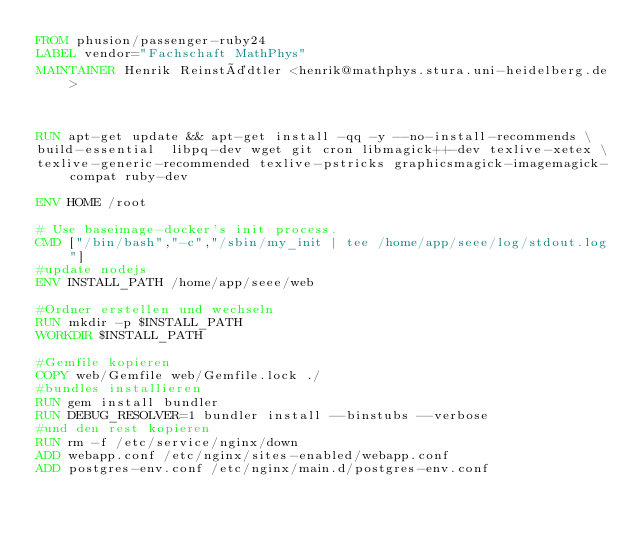Convert code to text. <code><loc_0><loc_0><loc_500><loc_500><_Dockerfile_>FROM phusion/passenger-ruby24
LABEL vendor="Fachschaft MathPhys"
MAINTAINER Henrik Reinstädtler <henrik@mathphys.stura.uni-heidelberg.de>



RUN apt-get update && apt-get install -qq -y --no-install-recommends \
build-essential  libpq-dev wget git cron libmagick++-dev texlive-xetex \
texlive-generic-recommended texlive-pstricks graphicsmagick-imagemagick-compat ruby-dev

ENV HOME /root

# Use baseimage-docker's init process.
CMD ["/bin/bash","-c","/sbin/my_init | tee /home/app/seee/log/stdout.log"]
#update nodejs
ENV INSTALL_PATH /home/app/seee/web

#Ordner erstellen und wechseln
RUN mkdir -p $INSTALL_PATH
WORKDIR $INSTALL_PATH

#Gemfile kopieren
COPY web/Gemfile web/Gemfile.lock ./
#bundles installieren
RUN gem install bundler
RUN DEBUG_RESOLVER=1 bundler install --binstubs --verbose
#und den rest kopieren
RUN rm -f /etc/service/nginx/down
ADD webapp.conf /etc/nginx/sites-enabled/webapp.conf
ADD postgres-env.conf /etc/nginx/main.d/postgres-env.conf</code> 